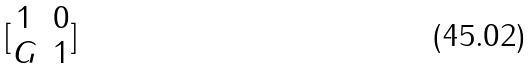Convert formula to latex. <formula><loc_0><loc_0><loc_500><loc_500>[ \begin{matrix} 1 & 0 \\ G & 1 \end{matrix} ]</formula> 